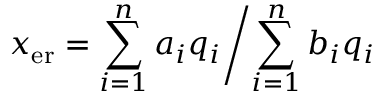<formula> <loc_0><loc_0><loc_500><loc_500>x _ { e r } = \sum _ { i = 1 } ^ { n } a _ { i } q _ { i } \Big / \sum _ { i = 1 } ^ { n } b _ { i } q _ { i }</formula> 